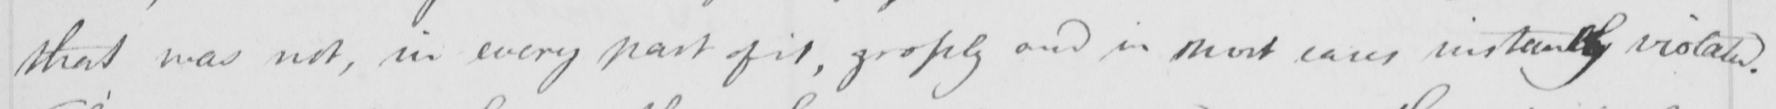Can you read and transcribe this handwriting? that was not , in every part of it , grossly and in most cases instantly violated . 